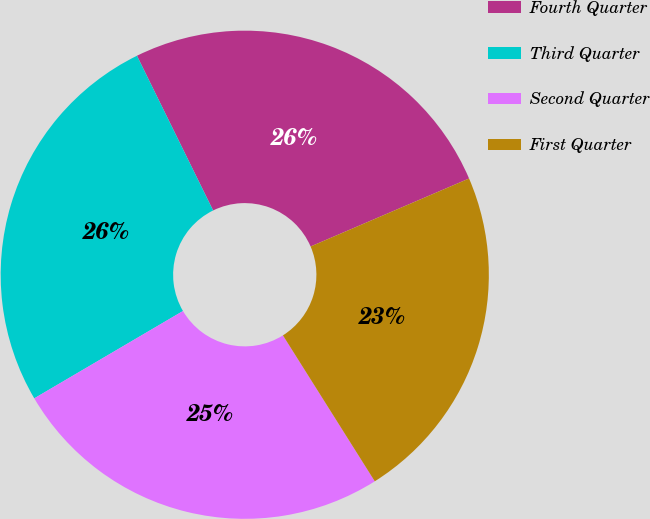Convert chart. <chart><loc_0><loc_0><loc_500><loc_500><pie_chart><fcel>Fourth Quarter<fcel>Third Quarter<fcel>Second Quarter<fcel>First Quarter<nl><fcel>25.83%<fcel>26.17%<fcel>25.49%<fcel>22.51%<nl></chart> 